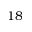<formula> <loc_0><loc_0><loc_500><loc_500>1 8</formula> 